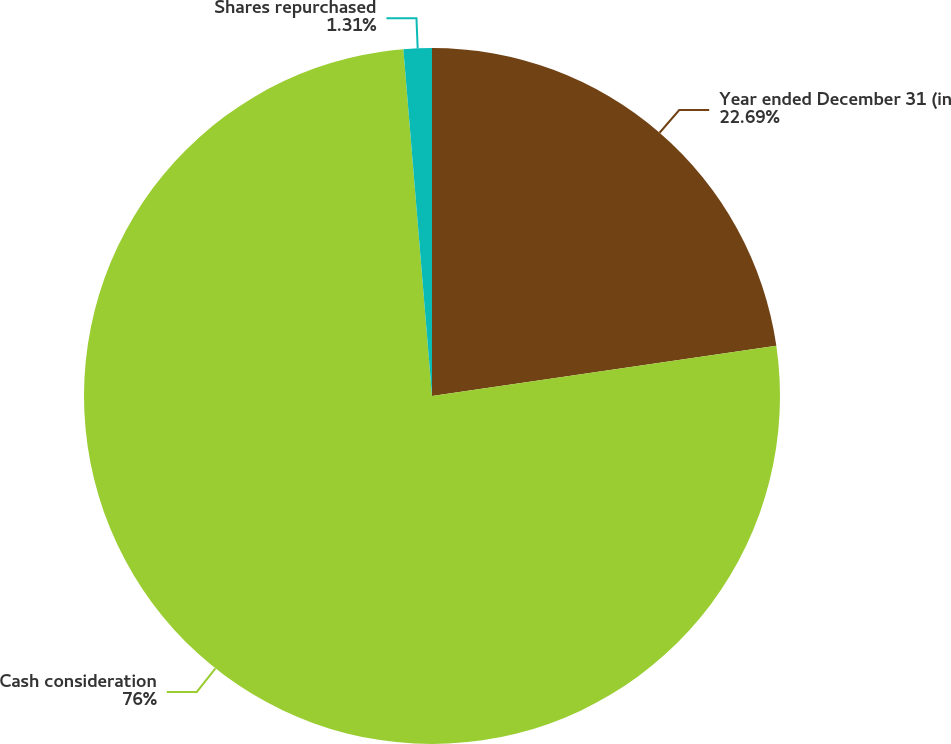Convert chart to OTSL. <chart><loc_0><loc_0><loc_500><loc_500><pie_chart><fcel>Year ended December 31 (in<fcel>Cash consideration<fcel>Shares repurchased<nl><fcel>22.69%<fcel>76.0%<fcel>1.31%<nl></chart> 